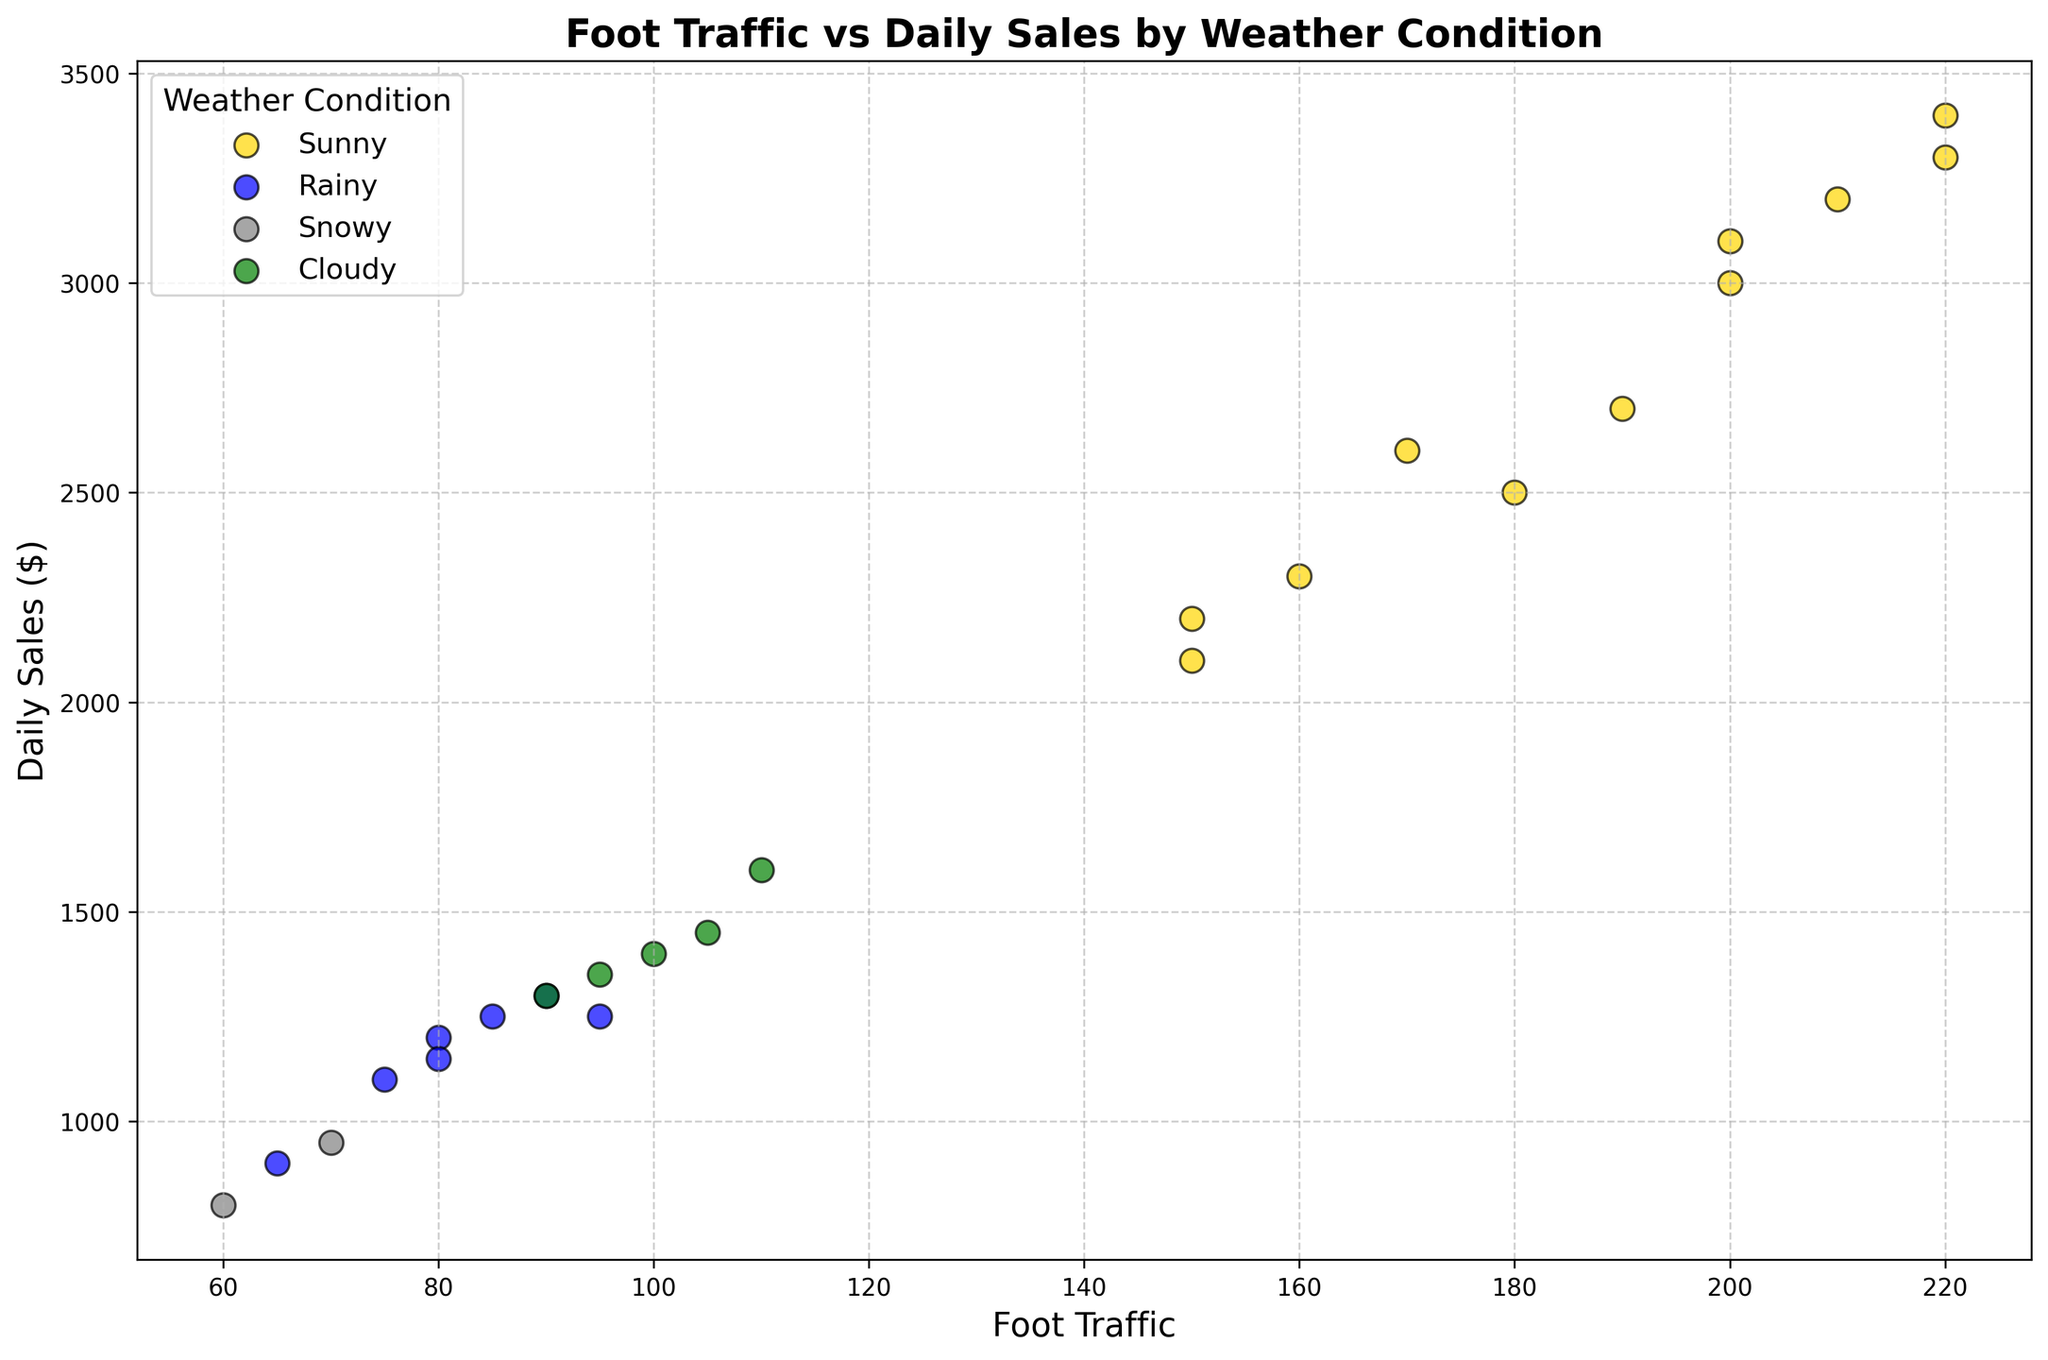What weather condition is associated with the highest daily sales observed in the figure? By examining the scatter plot and looking for the highest daily sales value, which is $3400, you can see that it corresponds to the points colored gold, indicating the weather condition is Sunny.
Answer: Sunny Which weather condition generally results in the lowest foot traffic? To determine this, observe which weather condition points are clustered toward the lower foot traffic values. Snowy data points (gray) generally have lower foot traffic values compared to other conditions.
Answer: Snowy What is the average daily sales for days with Rainy weather? Identify all blue points in the scatter plot (Rainy days) and sum their daily sales ($1200, $1300, $1100, $1250, $900, $1250, $1150). The average is calculated by dividing the total sum $8050 by the number of data points (7), resulting in approximately $1150.
Answer: $1150 Compare the daily sales on the busiest Sunny day versus the busiest Cloudy day. Locate the points with the highest foot traffic for Sunny (220) and for Cloudy (110). The daily sales for the busiest Sunny day are $3400, and for the busiest Cloudy day are $1600.
Answer: Sunny: $3400, Cloudy: $1600 What is the maximum foot traffic observed on Rainy days? Find the blue points on the plot and identify the one with the maximum foot traffic value, which is 95.
Answer: 95 How does foot traffic on snowy days compare to cloudy days? Look for gray points (Snowy) and green points (Cloudy) in the scatter plot. Snowy days have foot traffic values around 60 and 70, while Cloudy days range from 90 to 110. Generally, Snowy days have lower foot traffic than Cloudy days.
Answer: Snowy is lower than Cloudy What is the total daily sales on all Sunny days combined? Identify all gold points on the plot (Sunny days) and sum their daily sales ($2200, $3000, $2500, $3300, $3200, $2300, $2700, $3100, $2100, $3400, $2600). This results in a total of $30400.
Answer: $30400 Does higher foot traffic always equate to higher daily sales regardless of weather conditions? Observe the scatter plot to see if higher foot traffic points (toward right) consistently match with higher daily sales (upward). There are cases where this trend holds for weather like Sunny, but some points with high foot traffic in other weather conditions do not always follow this pattern. Therefore, higher foot traffic doesn't always equate to higher sales.
Answer: No What is the difference in daily sales between the sunniest day and the rainiest day? Identify the day with the highest foot traffic for Sunny (220, $3400) and for Rainy (95, $1250). The difference in daily sales is $3400 - $1250 = $2150.
Answer: $2150 What are the weather conditions for the three days with the highest daily sales? Look for the points at the top of the scatter plot to find the highest daily sales values which are $3400, $3300, and $3200. These points are all gold colored, indicating that Sunny weather conditions were present on all three days.
Answer: Sunny 